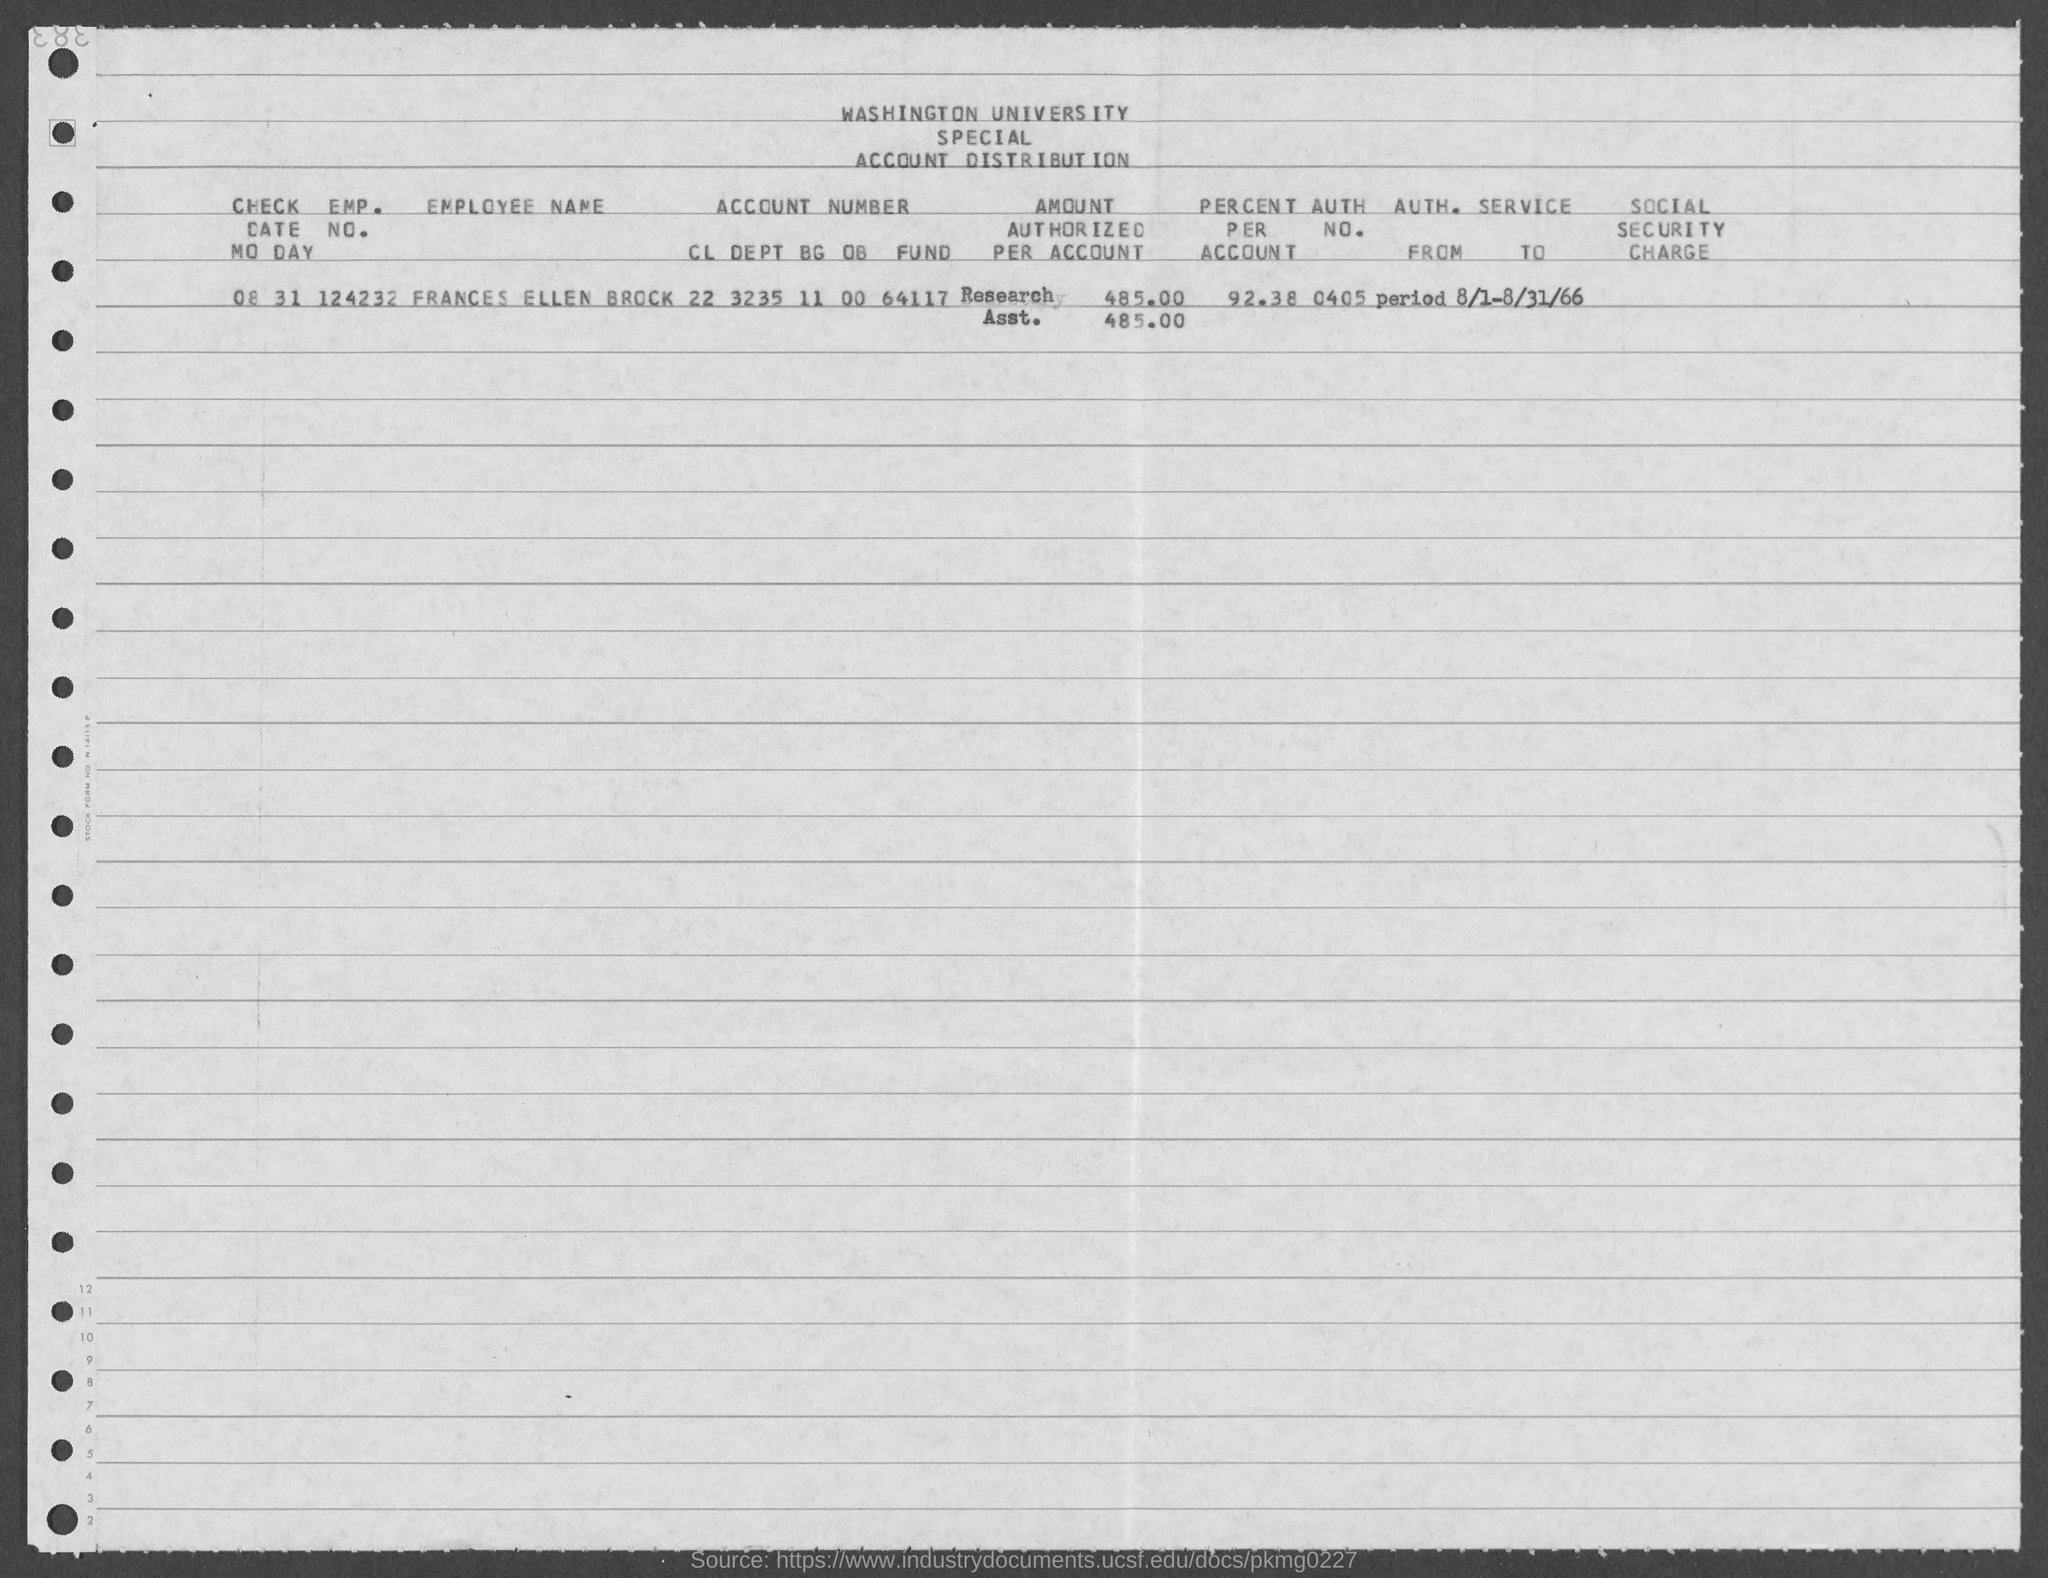Outline some significant characteristics in this image. The AUTH. NO. of FRANCES ELLEN BROCK is 0405... The amount authorized per account for FRANCES ELLEN BROCK is $485.00. The employee's name, FRANCES ELLEN BROCK, is stated in the document. FRANCES ELLEN BROCK has 92.38% of her accounts. The distribution of a university's account is given here. 